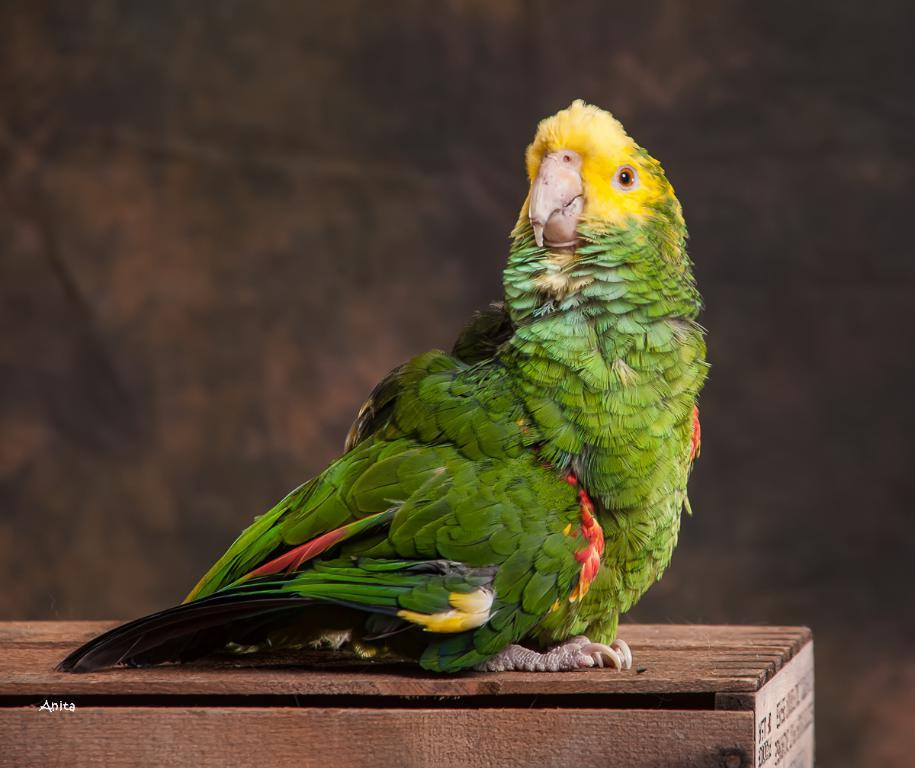What type of animal is in the image? There is a bird in the image. What colors can be seen on the bird? The bird has green, red, yellow, and white colors. What is the bird sitting on in the image? The bird is on a wooden object. What color is the wooden object? The wooden object is brown in color. How would you describe the background of the image? The background of the image is blurry. What type of soda is the bird holding in its beak in the image? There is no soda present in the image; it features a bird on a wooden object. What type of crate is the bird sitting on in the image? There is no crate present in the image; the bird is sitting on a wooden object. 